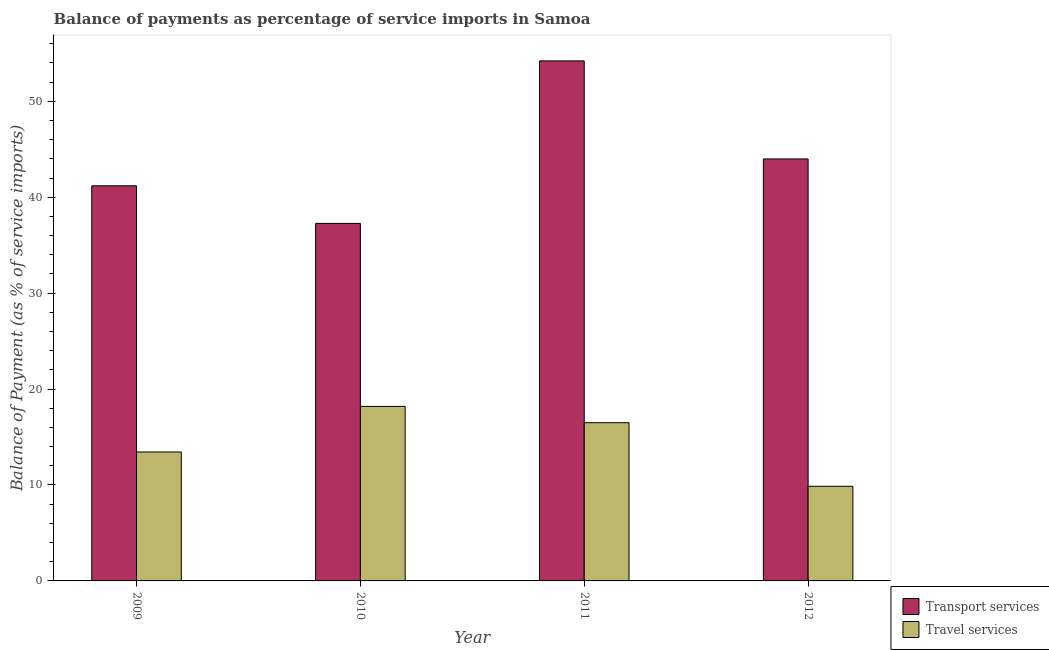Are the number of bars on each tick of the X-axis equal?
Your answer should be very brief. Yes. How many bars are there on the 2nd tick from the left?
Your answer should be very brief. 2. How many bars are there on the 1st tick from the right?
Give a very brief answer. 2. What is the balance of payments of travel services in 2009?
Make the answer very short. 13.44. Across all years, what is the maximum balance of payments of transport services?
Provide a short and direct response. 54.21. Across all years, what is the minimum balance of payments of transport services?
Make the answer very short. 37.27. In which year was the balance of payments of transport services minimum?
Offer a terse response. 2010. What is the total balance of payments of travel services in the graph?
Offer a very short reply. 57.99. What is the difference between the balance of payments of transport services in 2011 and that in 2012?
Offer a terse response. 10.22. What is the difference between the balance of payments of travel services in 2012 and the balance of payments of transport services in 2009?
Give a very brief answer. -3.58. What is the average balance of payments of transport services per year?
Your answer should be very brief. 44.16. In the year 2011, what is the difference between the balance of payments of travel services and balance of payments of transport services?
Your response must be concise. 0. What is the ratio of the balance of payments of travel services in 2009 to that in 2012?
Offer a terse response. 1.36. Is the balance of payments of transport services in 2009 less than that in 2011?
Give a very brief answer. Yes. What is the difference between the highest and the second highest balance of payments of travel services?
Give a very brief answer. 1.7. What is the difference between the highest and the lowest balance of payments of travel services?
Give a very brief answer. 8.33. In how many years, is the balance of payments of transport services greater than the average balance of payments of transport services taken over all years?
Your response must be concise. 1. Is the sum of the balance of payments of transport services in 2010 and 2011 greater than the maximum balance of payments of travel services across all years?
Your answer should be very brief. Yes. What does the 1st bar from the left in 2010 represents?
Offer a terse response. Transport services. What does the 1st bar from the right in 2009 represents?
Offer a terse response. Travel services. Are all the bars in the graph horizontal?
Your response must be concise. No. How many years are there in the graph?
Keep it short and to the point. 4. Are the values on the major ticks of Y-axis written in scientific E-notation?
Ensure brevity in your answer.  No. What is the title of the graph?
Offer a terse response. Balance of payments as percentage of service imports in Samoa. What is the label or title of the Y-axis?
Provide a short and direct response. Balance of Payment (as % of service imports). What is the Balance of Payment (as % of service imports) in Transport services in 2009?
Offer a very short reply. 41.19. What is the Balance of Payment (as % of service imports) in Travel services in 2009?
Your response must be concise. 13.44. What is the Balance of Payment (as % of service imports) of Transport services in 2010?
Offer a very short reply. 37.27. What is the Balance of Payment (as % of service imports) of Travel services in 2010?
Provide a succinct answer. 18.19. What is the Balance of Payment (as % of service imports) of Transport services in 2011?
Offer a terse response. 54.21. What is the Balance of Payment (as % of service imports) of Travel services in 2011?
Your answer should be very brief. 16.49. What is the Balance of Payment (as % of service imports) of Transport services in 2012?
Offer a very short reply. 43.99. What is the Balance of Payment (as % of service imports) in Travel services in 2012?
Your answer should be compact. 9.86. Across all years, what is the maximum Balance of Payment (as % of service imports) of Transport services?
Keep it short and to the point. 54.21. Across all years, what is the maximum Balance of Payment (as % of service imports) in Travel services?
Give a very brief answer. 18.19. Across all years, what is the minimum Balance of Payment (as % of service imports) in Transport services?
Make the answer very short. 37.27. Across all years, what is the minimum Balance of Payment (as % of service imports) in Travel services?
Provide a succinct answer. 9.86. What is the total Balance of Payment (as % of service imports) in Transport services in the graph?
Offer a very short reply. 176.66. What is the total Balance of Payment (as % of service imports) in Travel services in the graph?
Your answer should be compact. 57.99. What is the difference between the Balance of Payment (as % of service imports) in Transport services in 2009 and that in 2010?
Give a very brief answer. 3.92. What is the difference between the Balance of Payment (as % of service imports) of Travel services in 2009 and that in 2010?
Your response must be concise. -4.75. What is the difference between the Balance of Payment (as % of service imports) of Transport services in 2009 and that in 2011?
Your answer should be compact. -13.02. What is the difference between the Balance of Payment (as % of service imports) of Travel services in 2009 and that in 2011?
Give a very brief answer. -3.05. What is the difference between the Balance of Payment (as % of service imports) in Transport services in 2009 and that in 2012?
Your answer should be very brief. -2.8. What is the difference between the Balance of Payment (as % of service imports) in Travel services in 2009 and that in 2012?
Give a very brief answer. 3.58. What is the difference between the Balance of Payment (as % of service imports) in Transport services in 2010 and that in 2011?
Give a very brief answer. -16.94. What is the difference between the Balance of Payment (as % of service imports) of Travel services in 2010 and that in 2011?
Your response must be concise. 1.7. What is the difference between the Balance of Payment (as % of service imports) in Transport services in 2010 and that in 2012?
Provide a succinct answer. -6.72. What is the difference between the Balance of Payment (as % of service imports) of Travel services in 2010 and that in 2012?
Provide a succinct answer. 8.33. What is the difference between the Balance of Payment (as % of service imports) in Transport services in 2011 and that in 2012?
Make the answer very short. 10.22. What is the difference between the Balance of Payment (as % of service imports) of Travel services in 2011 and that in 2012?
Give a very brief answer. 6.63. What is the difference between the Balance of Payment (as % of service imports) in Transport services in 2009 and the Balance of Payment (as % of service imports) in Travel services in 2010?
Provide a short and direct response. 23. What is the difference between the Balance of Payment (as % of service imports) in Transport services in 2009 and the Balance of Payment (as % of service imports) in Travel services in 2011?
Keep it short and to the point. 24.7. What is the difference between the Balance of Payment (as % of service imports) of Transport services in 2009 and the Balance of Payment (as % of service imports) of Travel services in 2012?
Your answer should be very brief. 31.33. What is the difference between the Balance of Payment (as % of service imports) in Transport services in 2010 and the Balance of Payment (as % of service imports) in Travel services in 2011?
Provide a short and direct response. 20.78. What is the difference between the Balance of Payment (as % of service imports) of Transport services in 2010 and the Balance of Payment (as % of service imports) of Travel services in 2012?
Keep it short and to the point. 27.41. What is the difference between the Balance of Payment (as % of service imports) of Transport services in 2011 and the Balance of Payment (as % of service imports) of Travel services in 2012?
Offer a terse response. 44.35. What is the average Balance of Payment (as % of service imports) in Transport services per year?
Make the answer very short. 44.16. What is the average Balance of Payment (as % of service imports) in Travel services per year?
Provide a succinct answer. 14.5. In the year 2009, what is the difference between the Balance of Payment (as % of service imports) in Transport services and Balance of Payment (as % of service imports) in Travel services?
Give a very brief answer. 27.75. In the year 2010, what is the difference between the Balance of Payment (as % of service imports) in Transport services and Balance of Payment (as % of service imports) in Travel services?
Your answer should be very brief. 19.08. In the year 2011, what is the difference between the Balance of Payment (as % of service imports) in Transport services and Balance of Payment (as % of service imports) in Travel services?
Your response must be concise. 37.72. In the year 2012, what is the difference between the Balance of Payment (as % of service imports) in Transport services and Balance of Payment (as % of service imports) in Travel services?
Give a very brief answer. 34.12. What is the ratio of the Balance of Payment (as % of service imports) in Transport services in 2009 to that in 2010?
Give a very brief answer. 1.11. What is the ratio of the Balance of Payment (as % of service imports) in Travel services in 2009 to that in 2010?
Give a very brief answer. 0.74. What is the ratio of the Balance of Payment (as % of service imports) of Transport services in 2009 to that in 2011?
Your answer should be compact. 0.76. What is the ratio of the Balance of Payment (as % of service imports) of Travel services in 2009 to that in 2011?
Your answer should be compact. 0.81. What is the ratio of the Balance of Payment (as % of service imports) of Transport services in 2009 to that in 2012?
Provide a short and direct response. 0.94. What is the ratio of the Balance of Payment (as % of service imports) in Travel services in 2009 to that in 2012?
Give a very brief answer. 1.36. What is the ratio of the Balance of Payment (as % of service imports) in Transport services in 2010 to that in 2011?
Offer a terse response. 0.69. What is the ratio of the Balance of Payment (as % of service imports) in Travel services in 2010 to that in 2011?
Give a very brief answer. 1.1. What is the ratio of the Balance of Payment (as % of service imports) of Transport services in 2010 to that in 2012?
Your answer should be very brief. 0.85. What is the ratio of the Balance of Payment (as % of service imports) of Travel services in 2010 to that in 2012?
Keep it short and to the point. 1.84. What is the ratio of the Balance of Payment (as % of service imports) of Transport services in 2011 to that in 2012?
Give a very brief answer. 1.23. What is the ratio of the Balance of Payment (as % of service imports) in Travel services in 2011 to that in 2012?
Your response must be concise. 1.67. What is the difference between the highest and the second highest Balance of Payment (as % of service imports) of Transport services?
Offer a terse response. 10.22. What is the difference between the highest and the second highest Balance of Payment (as % of service imports) in Travel services?
Your response must be concise. 1.7. What is the difference between the highest and the lowest Balance of Payment (as % of service imports) in Transport services?
Provide a short and direct response. 16.94. What is the difference between the highest and the lowest Balance of Payment (as % of service imports) of Travel services?
Your answer should be very brief. 8.33. 